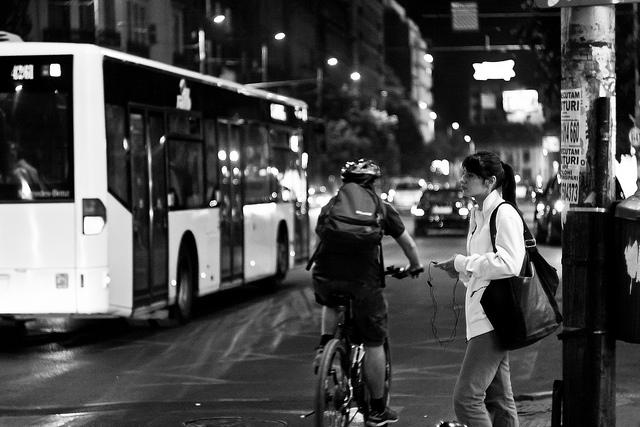What bus is the lady waiting for?
Keep it brief. City. What is on the pole?
Short answer required. Signs. Is the picture in black and white or color?
Quick response, please. Black and white. 